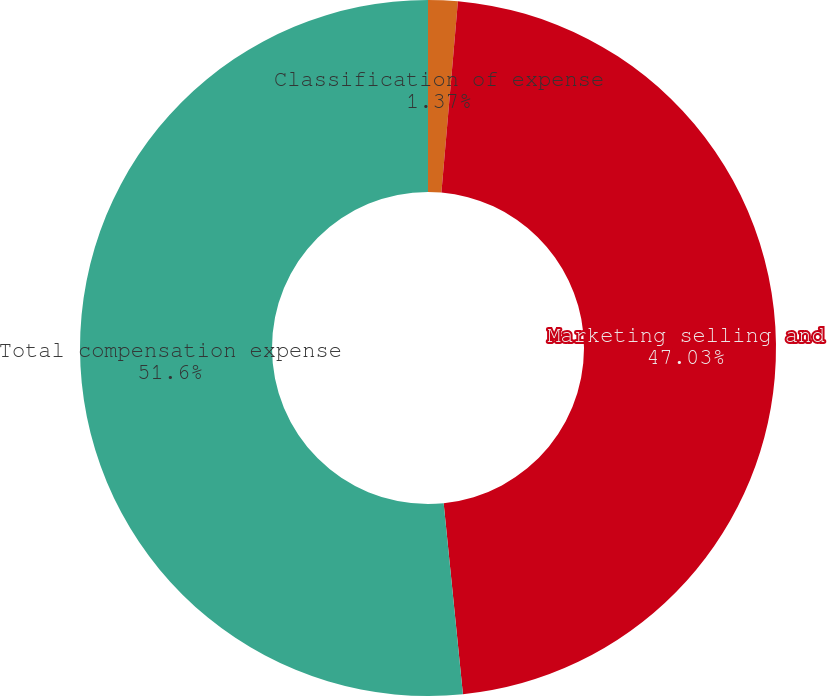Convert chart. <chart><loc_0><loc_0><loc_500><loc_500><pie_chart><fcel>Classification of expense<fcel>Marketing selling and<fcel>Total compensation expense<nl><fcel>1.37%<fcel>47.03%<fcel>51.6%<nl></chart> 